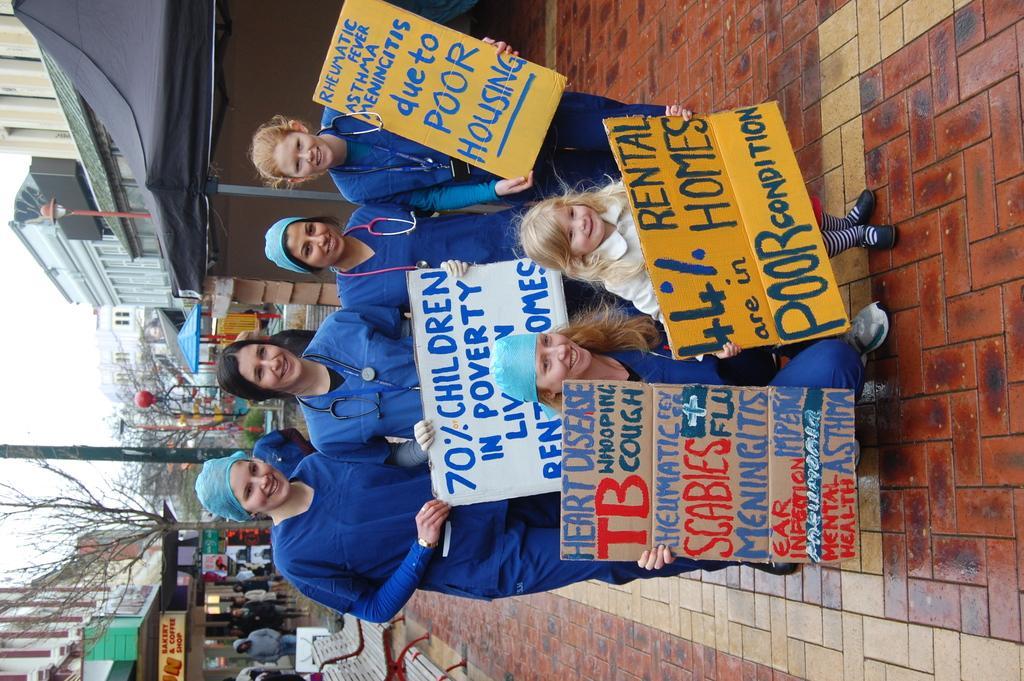Please provide a concise description of this image. In this image we can see people standing on the road and some of them are holding placards in their hands. In the background there are benches, trees, name boards, street poles, street lights, buildings, parasols and sky. 